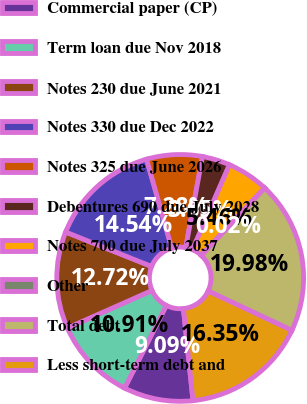Convert chart. <chart><loc_0><loc_0><loc_500><loc_500><pie_chart><fcel>Commercial paper (CP)<fcel>Term loan due Nov 2018<fcel>Notes 230 due June 2021<fcel>Notes 330 due Dec 2022<fcel>Notes 325 due June 2026<fcel>Debentures 690 due July 2028<fcel>Notes 700 due July 2037<fcel>Other<fcel>Total debt<fcel>Less short-term debt and<nl><fcel>9.09%<fcel>10.91%<fcel>12.72%<fcel>14.54%<fcel>7.28%<fcel>3.65%<fcel>5.46%<fcel>0.02%<fcel>19.98%<fcel>16.35%<nl></chart> 